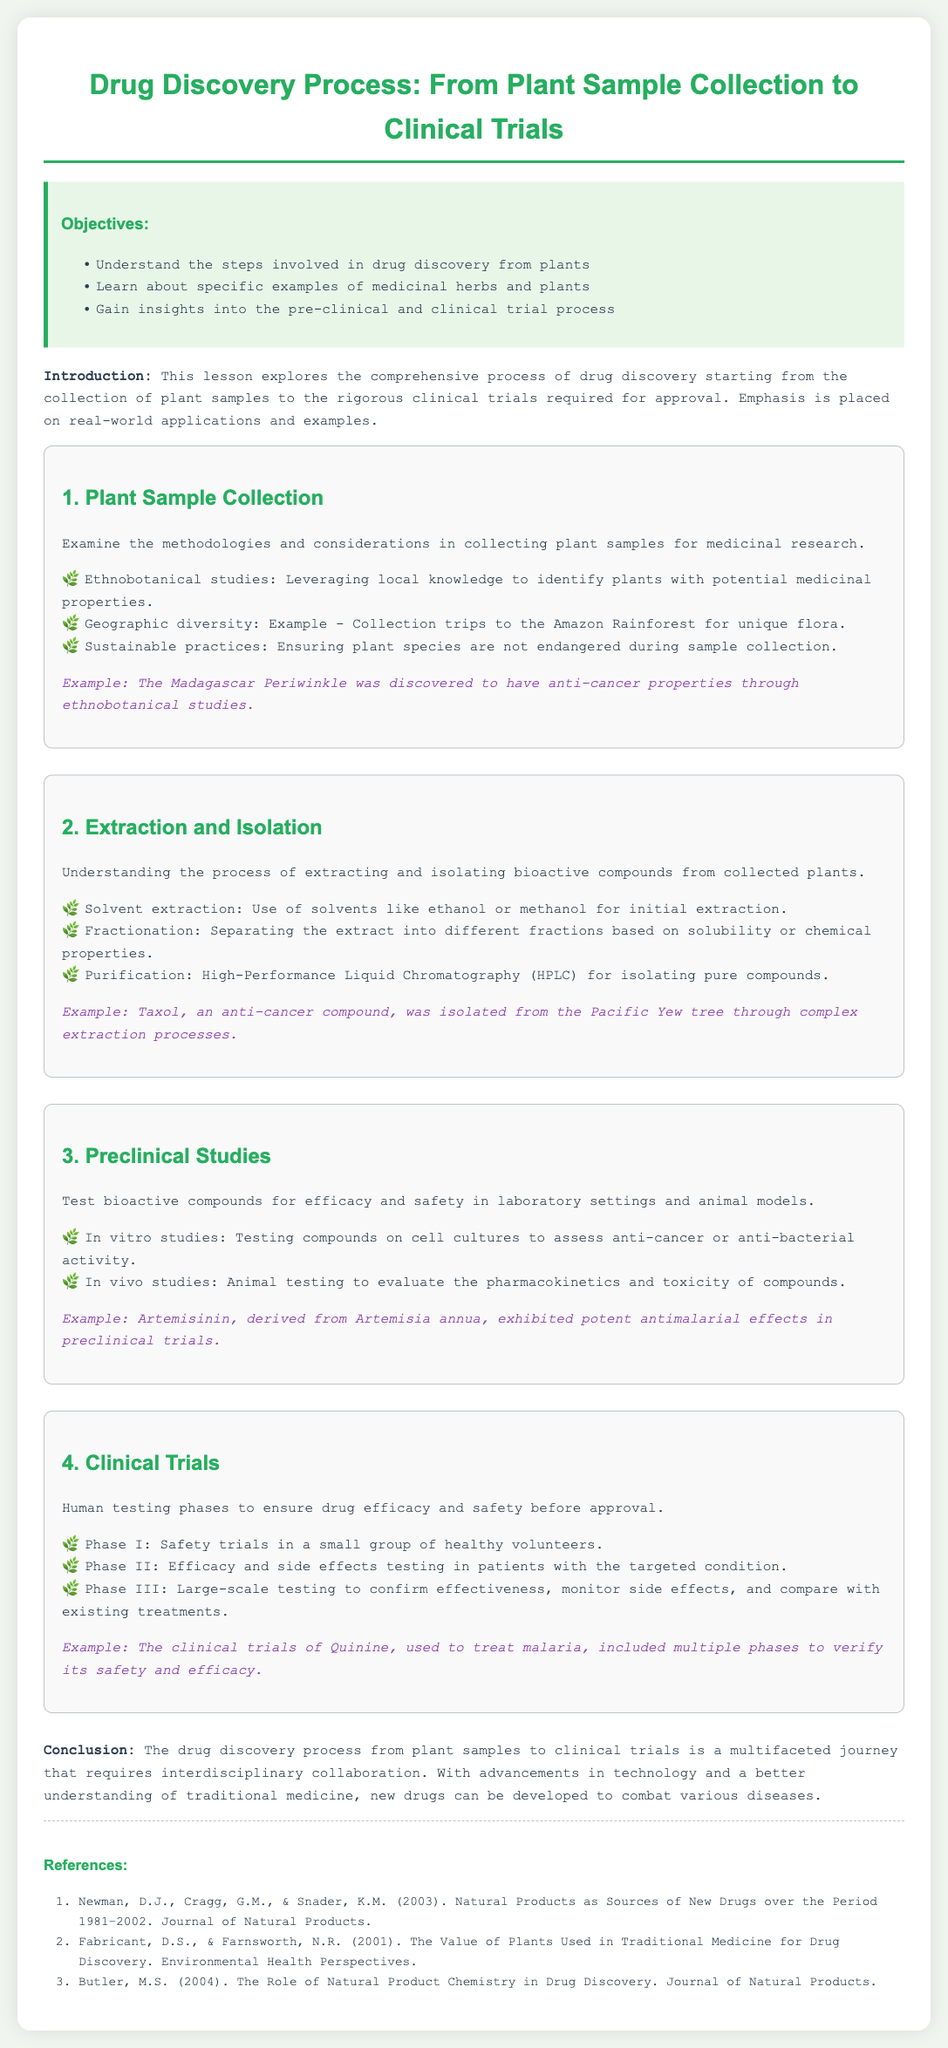What are the objectives of the lesson? The objectives are outlined in the document, which include understanding drug discovery, learning about medicinal herbs, and gaining insights into pre-clinical and clinical trials.
Answer: Understand the steps involved in drug discovery from plants, learn about specific examples of medicinal herbs and plants, gain insights into the pre-clinical and clinical trial process What methodology is emphasized for plant sample collection? The document mentions methodologies like ethnobotanical studies and geographic diversity.
Answer: Ethnobotanical studies What is an example of a plant with anti-cancer properties? The document provides an example of the Madagascar Periwinkle related to anti-cancer properties discovered through studies.
Answer: Madagascar Periwinkle What extraction technique is used for initial extraction? The document states the use of solvents like ethanol or methanol for the initial extraction method.
Answer: Solvent extraction What type of studies are conducted during preclinical research? The document describes in vitro and in vivo studies as part of preclinical research.
Answer: In vitro studies What phase follows safety trials in clinical trials? The document outlines that Phase II follows after Phase I, focusing on efficacy and side effects.
Answer: Phase II What compound was isolated from the Pacific Yew tree? The document gives the name of a well-known compound, Taxol, derived through extraction from the tree.
Answer: Taxol How many phases are there in clinical trials as mentioned in the document? The document lists three major phases of clinical trials, focusing on various testing aspects.
Answer: Three phases 